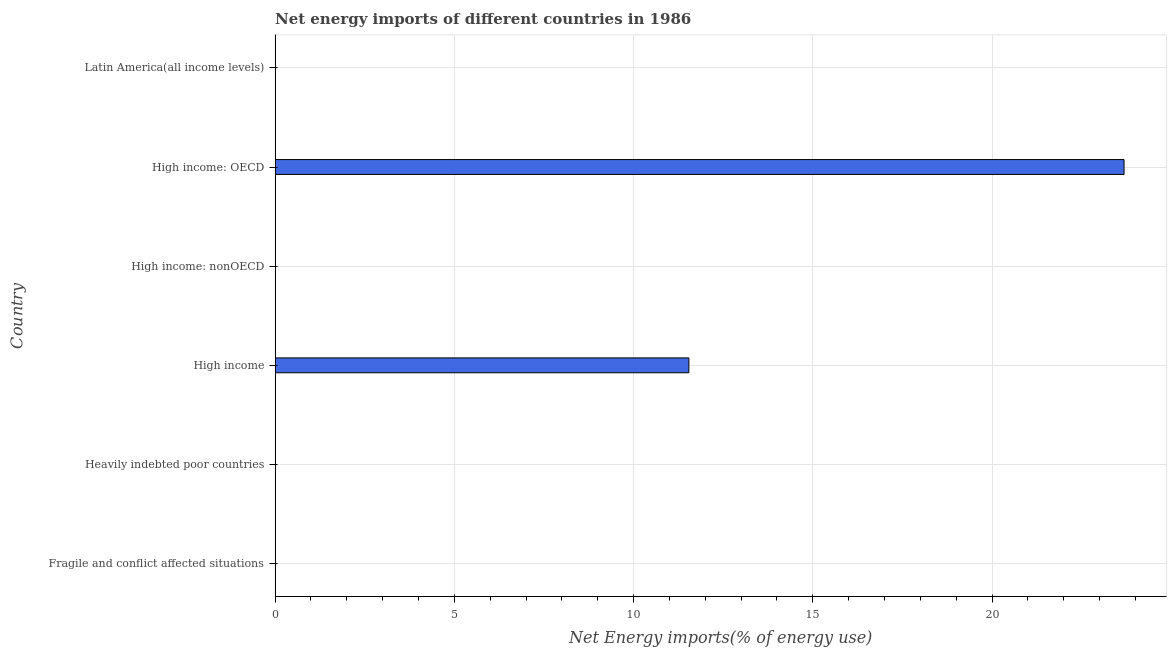What is the title of the graph?
Provide a short and direct response. Net energy imports of different countries in 1986. What is the label or title of the X-axis?
Provide a succinct answer. Net Energy imports(% of energy use). What is the label or title of the Y-axis?
Keep it short and to the point. Country. What is the energy imports in Heavily indebted poor countries?
Your answer should be compact. 0. Across all countries, what is the maximum energy imports?
Provide a short and direct response. 23.68. Across all countries, what is the minimum energy imports?
Your response must be concise. 0. In which country was the energy imports maximum?
Your answer should be very brief. High income: OECD. What is the sum of the energy imports?
Offer a terse response. 35.22. What is the difference between the energy imports in High income and High income: OECD?
Ensure brevity in your answer.  -12.14. What is the average energy imports per country?
Keep it short and to the point. 5.87. In how many countries, is the energy imports greater than 10 %?
Offer a terse response. 2. What is the ratio of the energy imports in High income to that in High income: OECD?
Your answer should be very brief. 0.49. What is the difference between the highest and the lowest energy imports?
Your answer should be compact. 23.68. How many bars are there?
Keep it short and to the point. 2. Are all the bars in the graph horizontal?
Your answer should be very brief. Yes. What is the Net Energy imports(% of energy use) in High income?
Offer a very short reply. 11.54. What is the Net Energy imports(% of energy use) in High income: OECD?
Give a very brief answer. 23.68. What is the Net Energy imports(% of energy use) in Latin America(all income levels)?
Your response must be concise. 0. What is the difference between the Net Energy imports(% of energy use) in High income and High income: OECD?
Provide a succinct answer. -12.14. What is the ratio of the Net Energy imports(% of energy use) in High income to that in High income: OECD?
Provide a succinct answer. 0.49. 